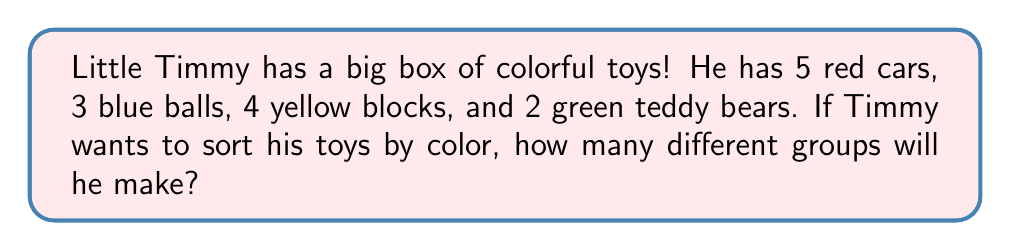Show me your answer to this math problem. Let's count the different colors of toys Timmy has:

1. Red toys: The cars are red
2. Blue toys: The balls are blue
3. Yellow toys: The blocks are yellow
4. Green toys: The teddy bears are green

To find out how many groups Timmy will make when sorting by color, we just need to count the number of different colors:

$$ \text{Number of groups} = \text{Number of different colors} $$

We can see that Timmy has toys in 4 different colors: red, blue, yellow, and green.

So, when Timmy sorts his toys by color, he will make 4 different groups.
Answer: 4 groups 